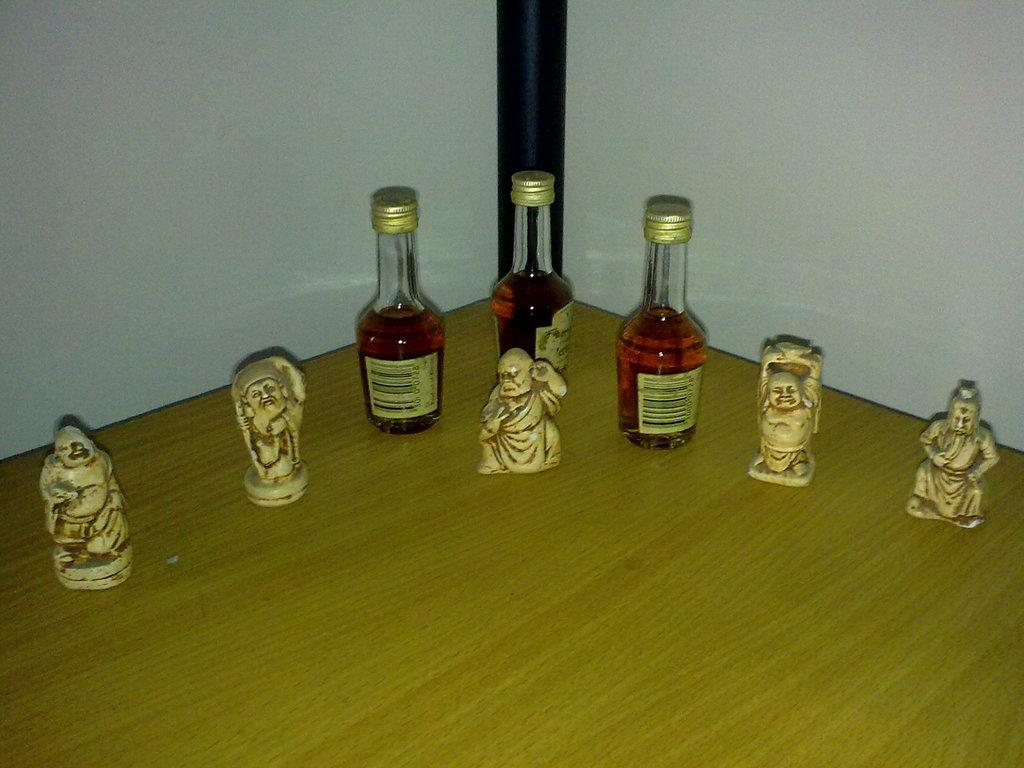How many bottles are on the table in the image? There are three bottles on the table in the image. What else can be seen on the table besides the bottles? There are sculptures on the table. What type of collar is visible on the sculpture in the image? There is no collar present on the sculpture in the image, as it is not a living being. How many quilts are draped over the bottles in the image? There are no quilts present in the image; only bottles and sculptures are visible. 